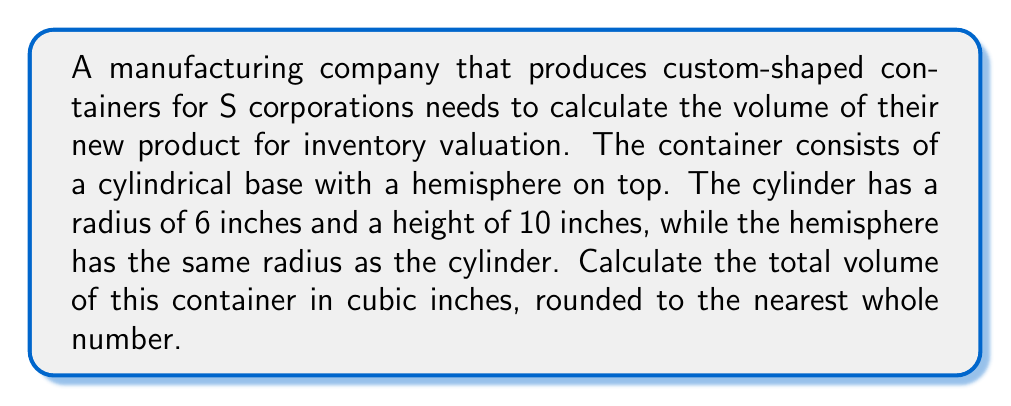Provide a solution to this math problem. To solve this problem, we'll calculate the volumes of the cylinder and hemisphere separately, then add them together.

1. Volume of the cylinder:
   The formula for the volume of a cylinder is $V_{cylinder} = \pi r^2 h$
   where $r$ is the radius and $h$ is the height.
   
   $V_{cylinder} = \pi \cdot 6^2 \cdot 10 = 360\pi$ cubic inches

2. Volume of the hemisphere:
   The formula for the volume of a hemisphere is $V_{hemisphere} = \frac{2}{3}\pi r^3$
   
   $V_{hemisphere} = \frac{2}{3}\pi \cdot 6^3 = 144\pi$ cubic inches

3. Total volume:
   $V_{total} = V_{cylinder} + V_{hemisphere}$
   $V_{total} = 360\pi + 144\pi = 504\pi$ cubic inches

4. Evaluating and rounding:
   $V_{total} = 504\pi \approx 1,583.36$ cubic inches
   Rounded to the nearest whole number: 1,583 cubic inches

This volume calculation is crucial for accurate inventory valuation, which is an important aspect of financial reporting for S corporations.
Answer: 1,583 cubic inches 